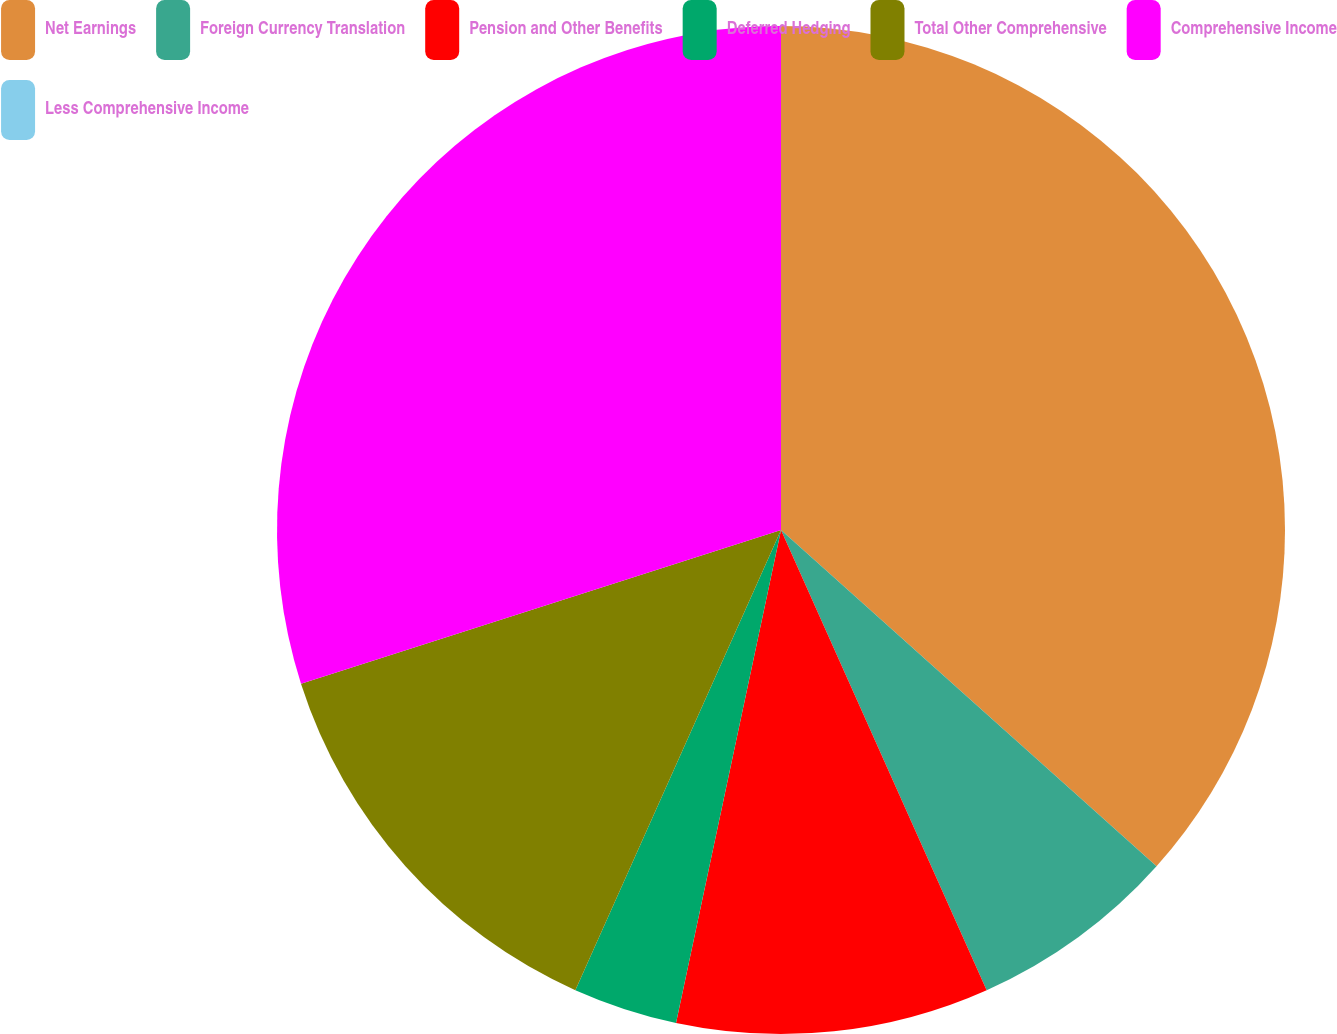Convert chart. <chart><loc_0><loc_0><loc_500><loc_500><pie_chart><fcel>Net Earnings<fcel>Foreign Currency Translation<fcel>Pension and Other Benefits<fcel>Deferred Hedging<fcel>Total Other Comprehensive<fcel>Comprehensive Income<fcel>Less Comprehensive Income<nl><fcel>36.62%<fcel>6.69%<fcel>10.03%<fcel>3.35%<fcel>13.38%<fcel>29.93%<fcel>0.0%<nl></chart> 